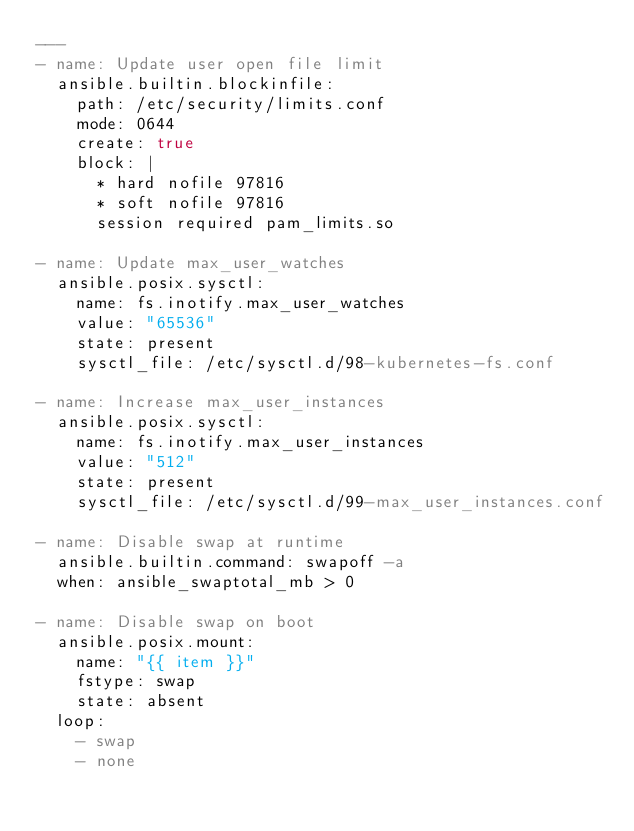Convert code to text. <code><loc_0><loc_0><loc_500><loc_500><_YAML_>---
- name: Update user open file limit
  ansible.builtin.blockinfile:
    path: /etc/security/limits.conf
    mode: 0644
    create: true
    block: |
      * hard nofile 97816
      * soft nofile 97816
      session required pam_limits.so

- name: Update max_user_watches
  ansible.posix.sysctl:
    name: fs.inotify.max_user_watches
    value: "65536"
    state: present
    sysctl_file: /etc/sysctl.d/98-kubernetes-fs.conf

- name: Increase max_user_instances
  ansible.posix.sysctl:
    name: fs.inotify.max_user_instances
    value: "512"
    state: present
    sysctl_file: /etc/sysctl.d/99-max_user_instances.conf

- name: Disable swap at runtime
  ansible.builtin.command: swapoff -a
  when: ansible_swaptotal_mb > 0

- name: Disable swap on boot
  ansible.posix.mount:
    name: "{{ item }}"
    fstype: swap
    state: absent
  loop:
    - swap
    - none

</code> 